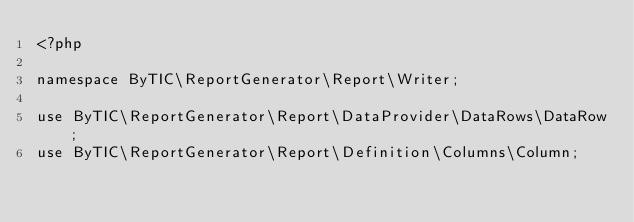<code> <loc_0><loc_0><loc_500><loc_500><_PHP_><?php

namespace ByTIC\ReportGenerator\Report\Writer;

use ByTIC\ReportGenerator\Report\DataProvider\DataRows\DataRow;
use ByTIC\ReportGenerator\Report\Definition\Columns\Column;</code> 